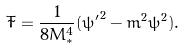Convert formula to latex. <formula><loc_0><loc_0><loc_500><loc_500>\tilde { T } = \frac { 1 } { 8 M _ { * } ^ { 4 } } ( { \psi ^ { \prime } } ^ { 2 } - m ^ { 2 } \psi ^ { 2 } ) .</formula> 